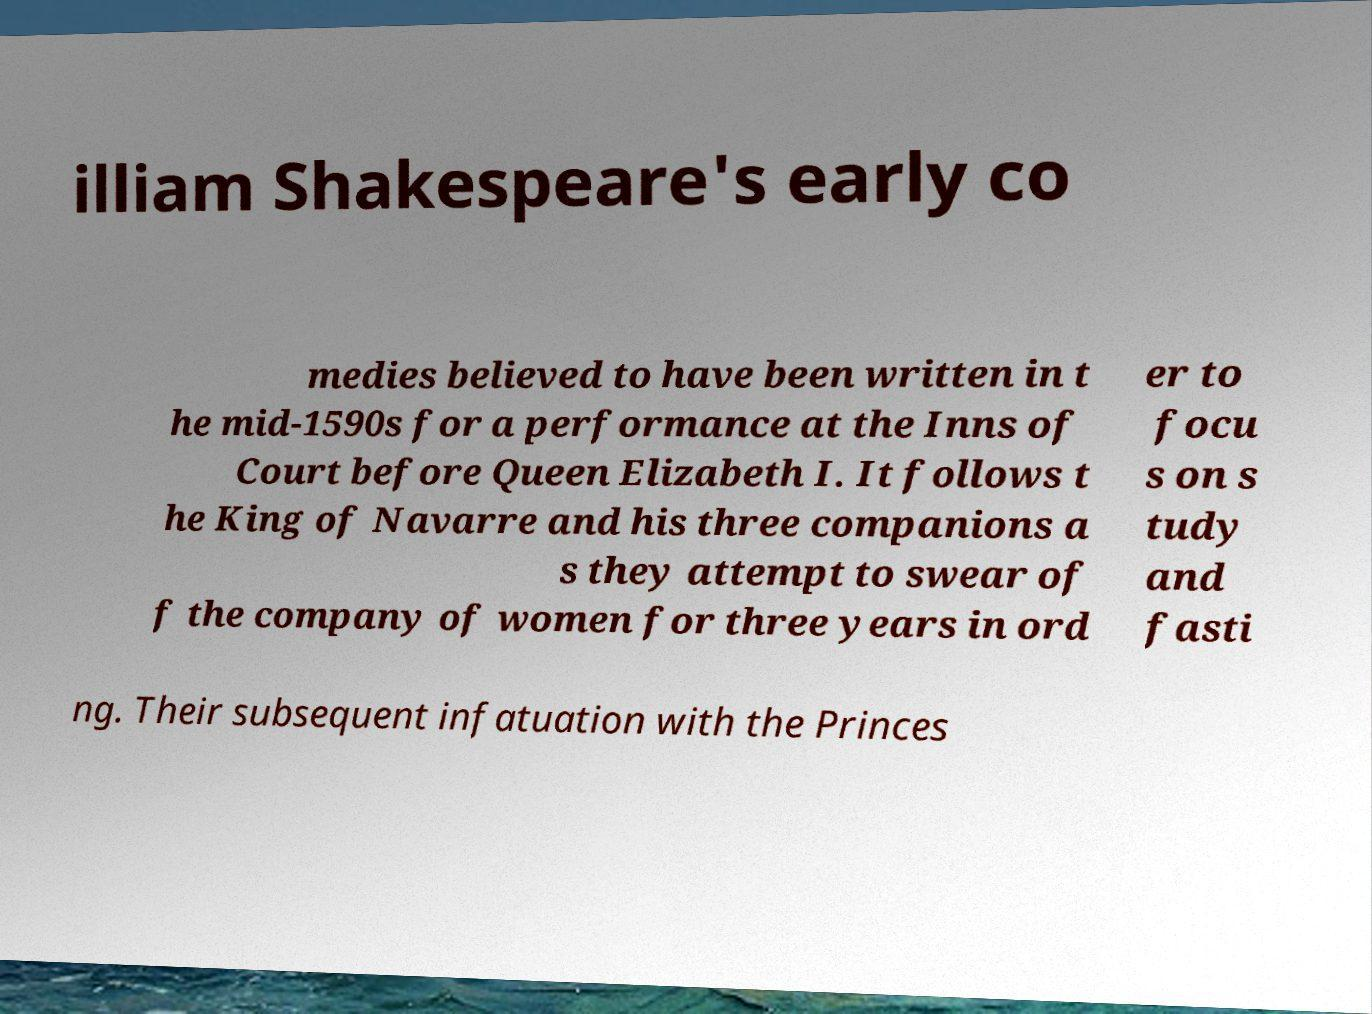What messages or text are displayed in this image? I need them in a readable, typed format. illiam Shakespeare's early co medies believed to have been written in t he mid-1590s for a performance at the Inns of Court before Queen Elizabeth I. It follows t he King of Navarre and his three companions a s they attempt to swear of f the company of women for three years in ord er to focu s on s tudy and fasti ng. Their subsequent infatuation with the Princes 